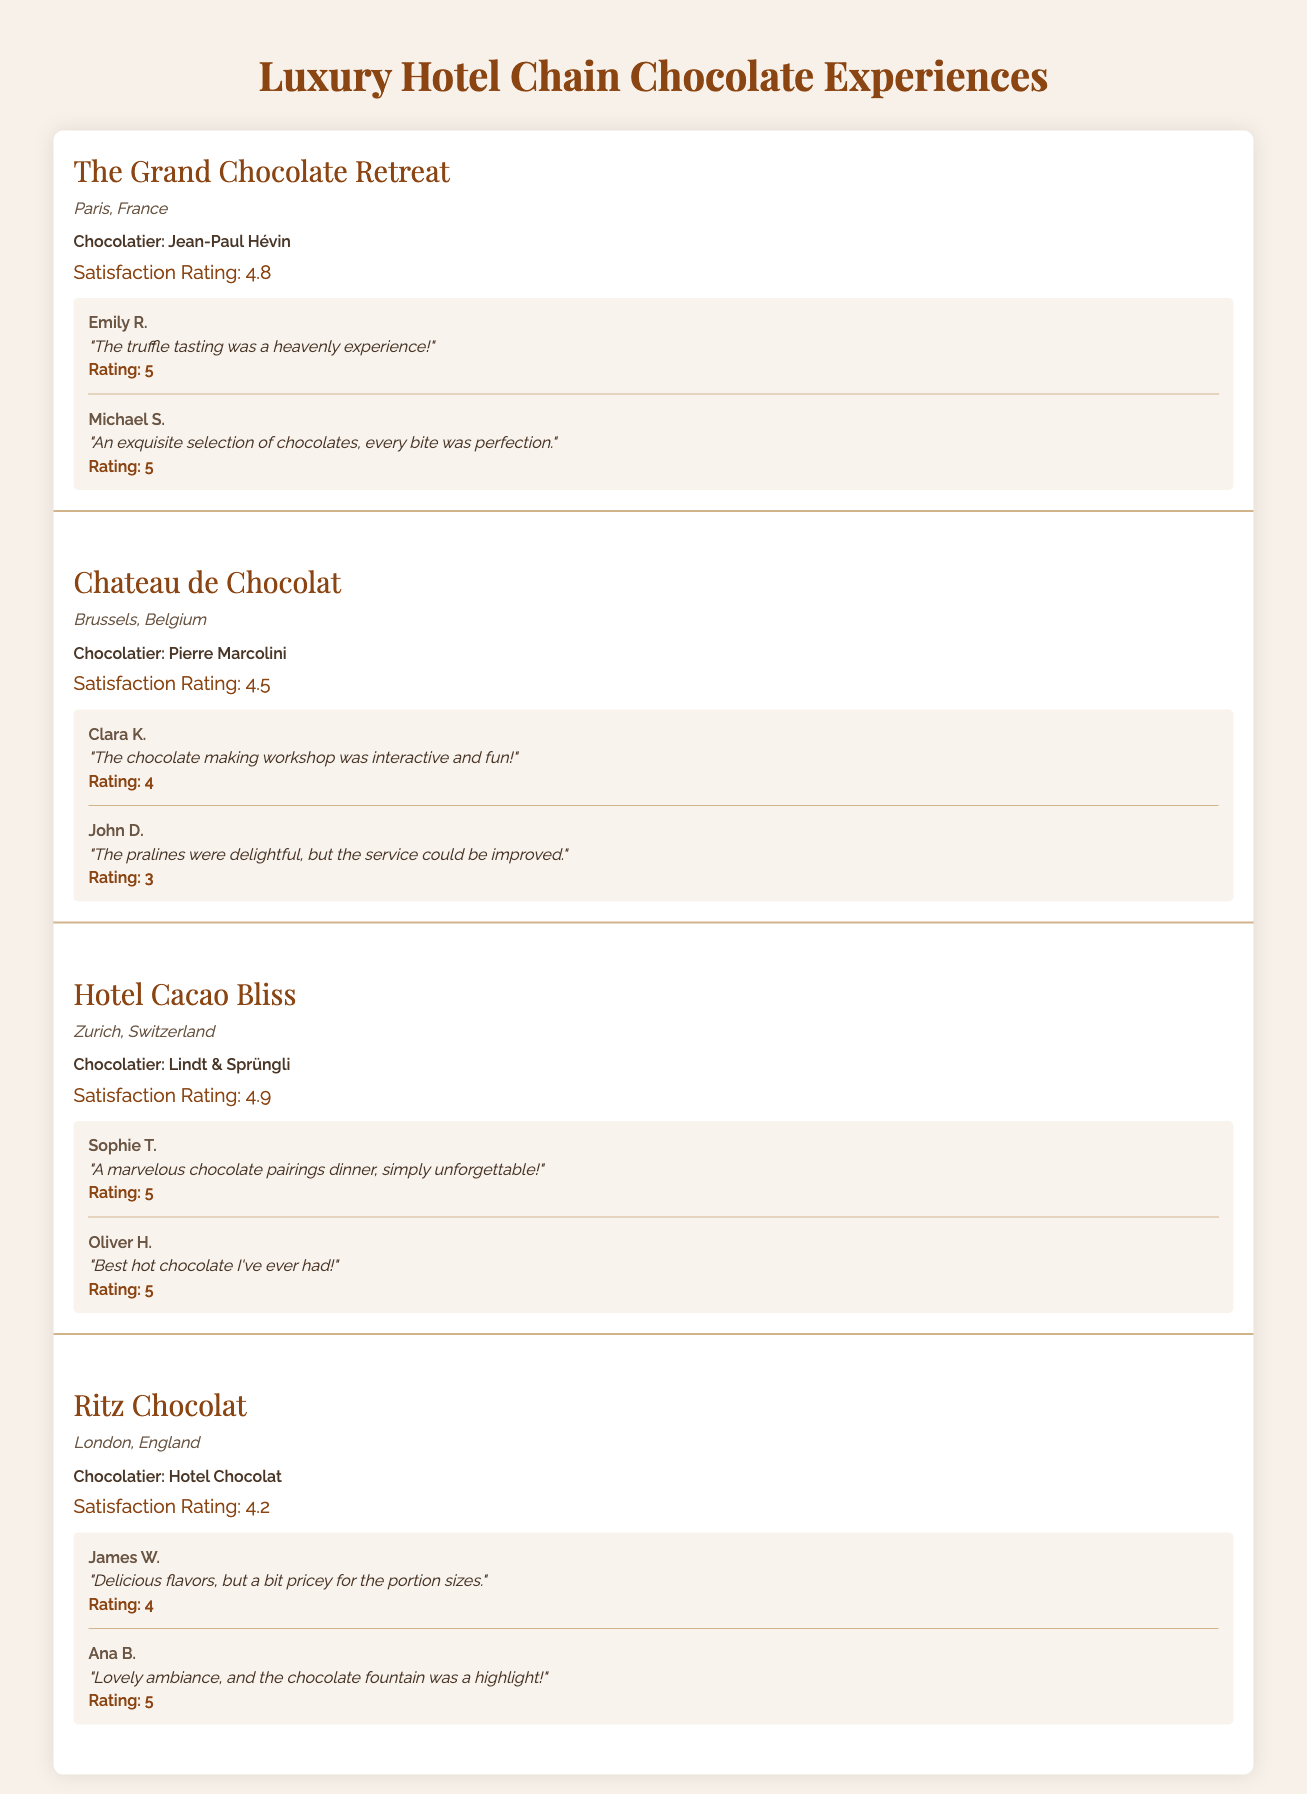What is the satisfaction rating of Hotel Cacao Bliss? The table shows that the satisfaction rating for Hotel Cacao Bliss is listed as 4.9.
Answer: 4.9 Which chocolatier is associated with The Grand Chocolate Retreat? According to the table, Jean-Paul Hévin is the chocolatier for The Grand Chocolate Retreat.
Answer: Jean-Paul Hévin What is the average satisfaction rating across all hotel locations? The satisfaction ratings are 4.8, 4.5, 4.9, and 4.2. To find the average: (4.8 + 4.5 + 4.9 + 4.2) / 4 = 4.575.
Answer: 4.575 Did any guest provide a feedback rating of 3 at Chateau de Chocolat? Yes, John D. provided a feedback rating of 3 at Chateau de Chocolat, as stated in the table.
Answer: Yes Which hotel location has the highest satisfaction rating? Hotel Cacao Bliss has the highest satisfaction rating of 4.9, while others are lower.
Answer: Hotel Cacao Bliss What is the total number of feedbacks from guests at The Grand Chocolate Retreat? The table shows two feedbacks provided by guests at The Grand Chocolate Retreat, from Emily R. and Michael S.
Answer: 2 Is the comment by Clara K. at Chateau de Chocolat positive? Clara K.'s comment is positive, stating, "The chocolate making workshop was interactive and fun!" which corresponds with a rating of 4.
Answer: Yes What is the difference between the highest and lowest satisfaction rating? The highest rating is 4.9 from Hotel Cacao Bliss, and the lowest is 4.2 from Ritz Chocolat. The difference is 4.9 - 4.2 = 0.7.
Answer: 0.7 How many guests rated their experience at Ritz Chocolat? There are two guests listed in the feedback section for Ritz Chocolat: James W. and Ana B.
Answer: 2 Which hotel has feedback indicating a need for service improvement? The feedback from John D. at Chateau de Chocolat indicates that "the service could be improved," highlighting a need for service improvements.
Answer: Chateau de Chocolat 